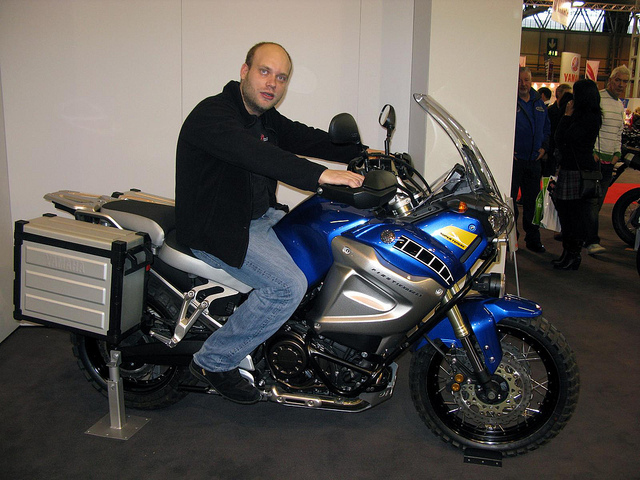<image>What tool is the motorcyclist carrying? I don't know what tool the motorcyclist is carrying. It could be a toolbox, key, flashlight, wrench, or side saddles. Who make of motorcycle is this? I don't know the make of the motorcycle. It could be Yamaha, Kawasaki, Suzuki, Harley, or Honda. What tool is the motorcyclist carrying? It is unknown what tool the motorcyclist is carrying. Who make of motorcycle is this? I don't know who make of motorcycle this is. It can be Yamaha, Kawasaki, Suzuki, Harley, or Honda. 